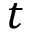<formula> <loc_0><loc_0><loc_500><loc_500>t</formula> 